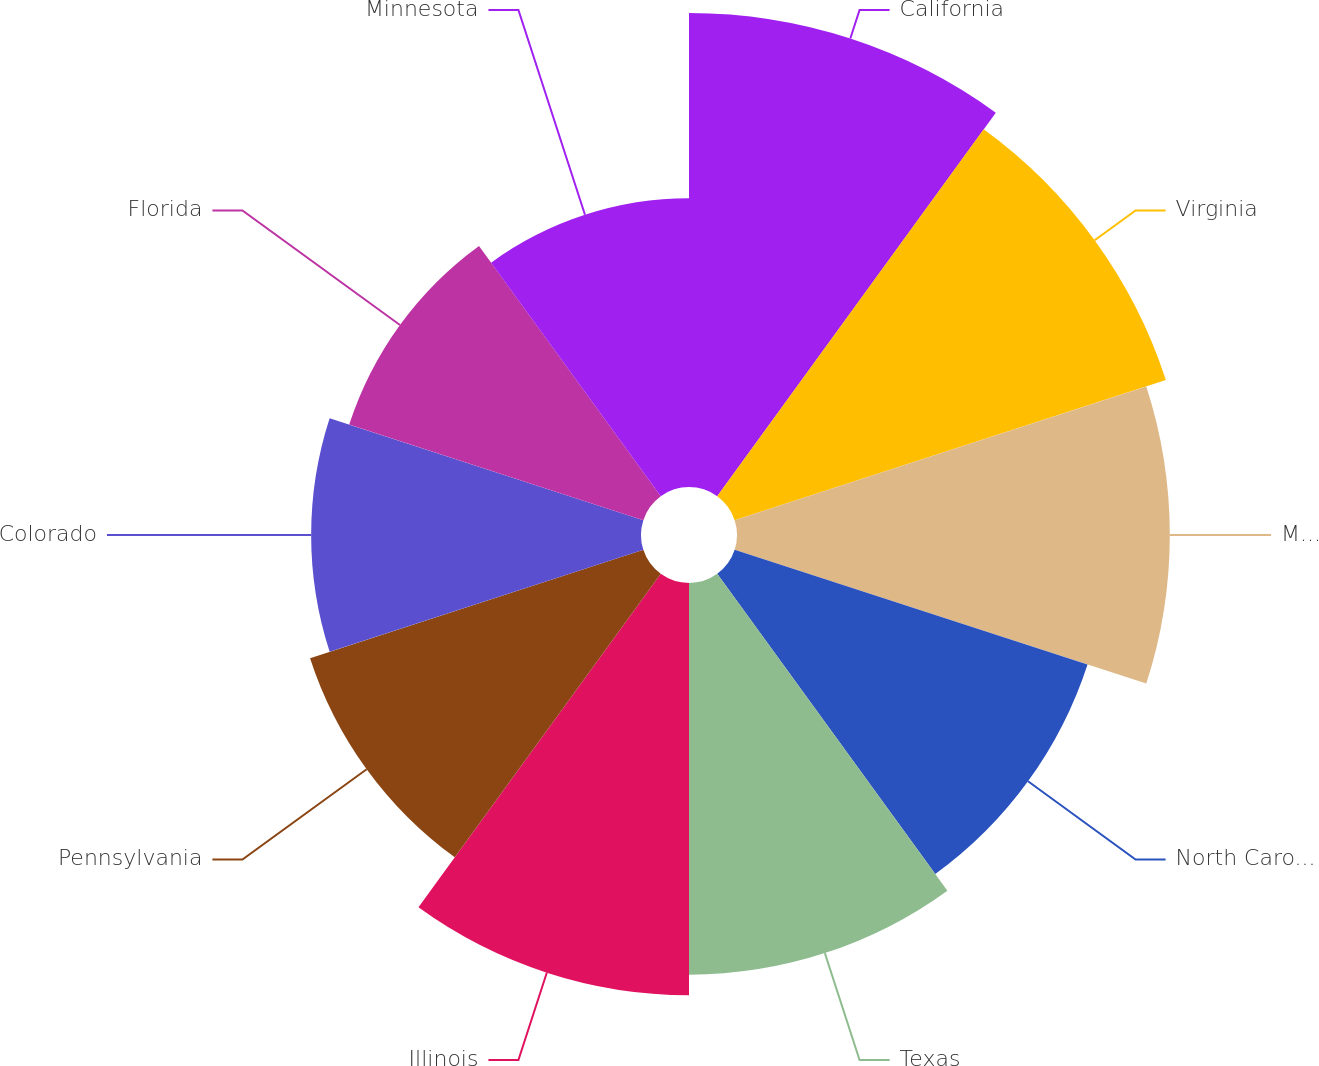<chart> <loc_0><loc_0><loc_500><loc_500><pie_chart><fcel>California<fcel>Virginia<fcel>Maryland<fcel>North Carolina<fcel>Texas<fcel>Illinois<fcel>Pennsylvania<fcel>Colorado<fcel>Florida<fcel>Minnesota<nl><fcel>12.43%<fcel>11.89%<fcel>11.35%<fcel>9.73%<fcel>10.27%<fcel>10.81%<fcel>9.19%<fcel>8.65%<fcel>8.11%<fcel>7.57%<nl></chart> 